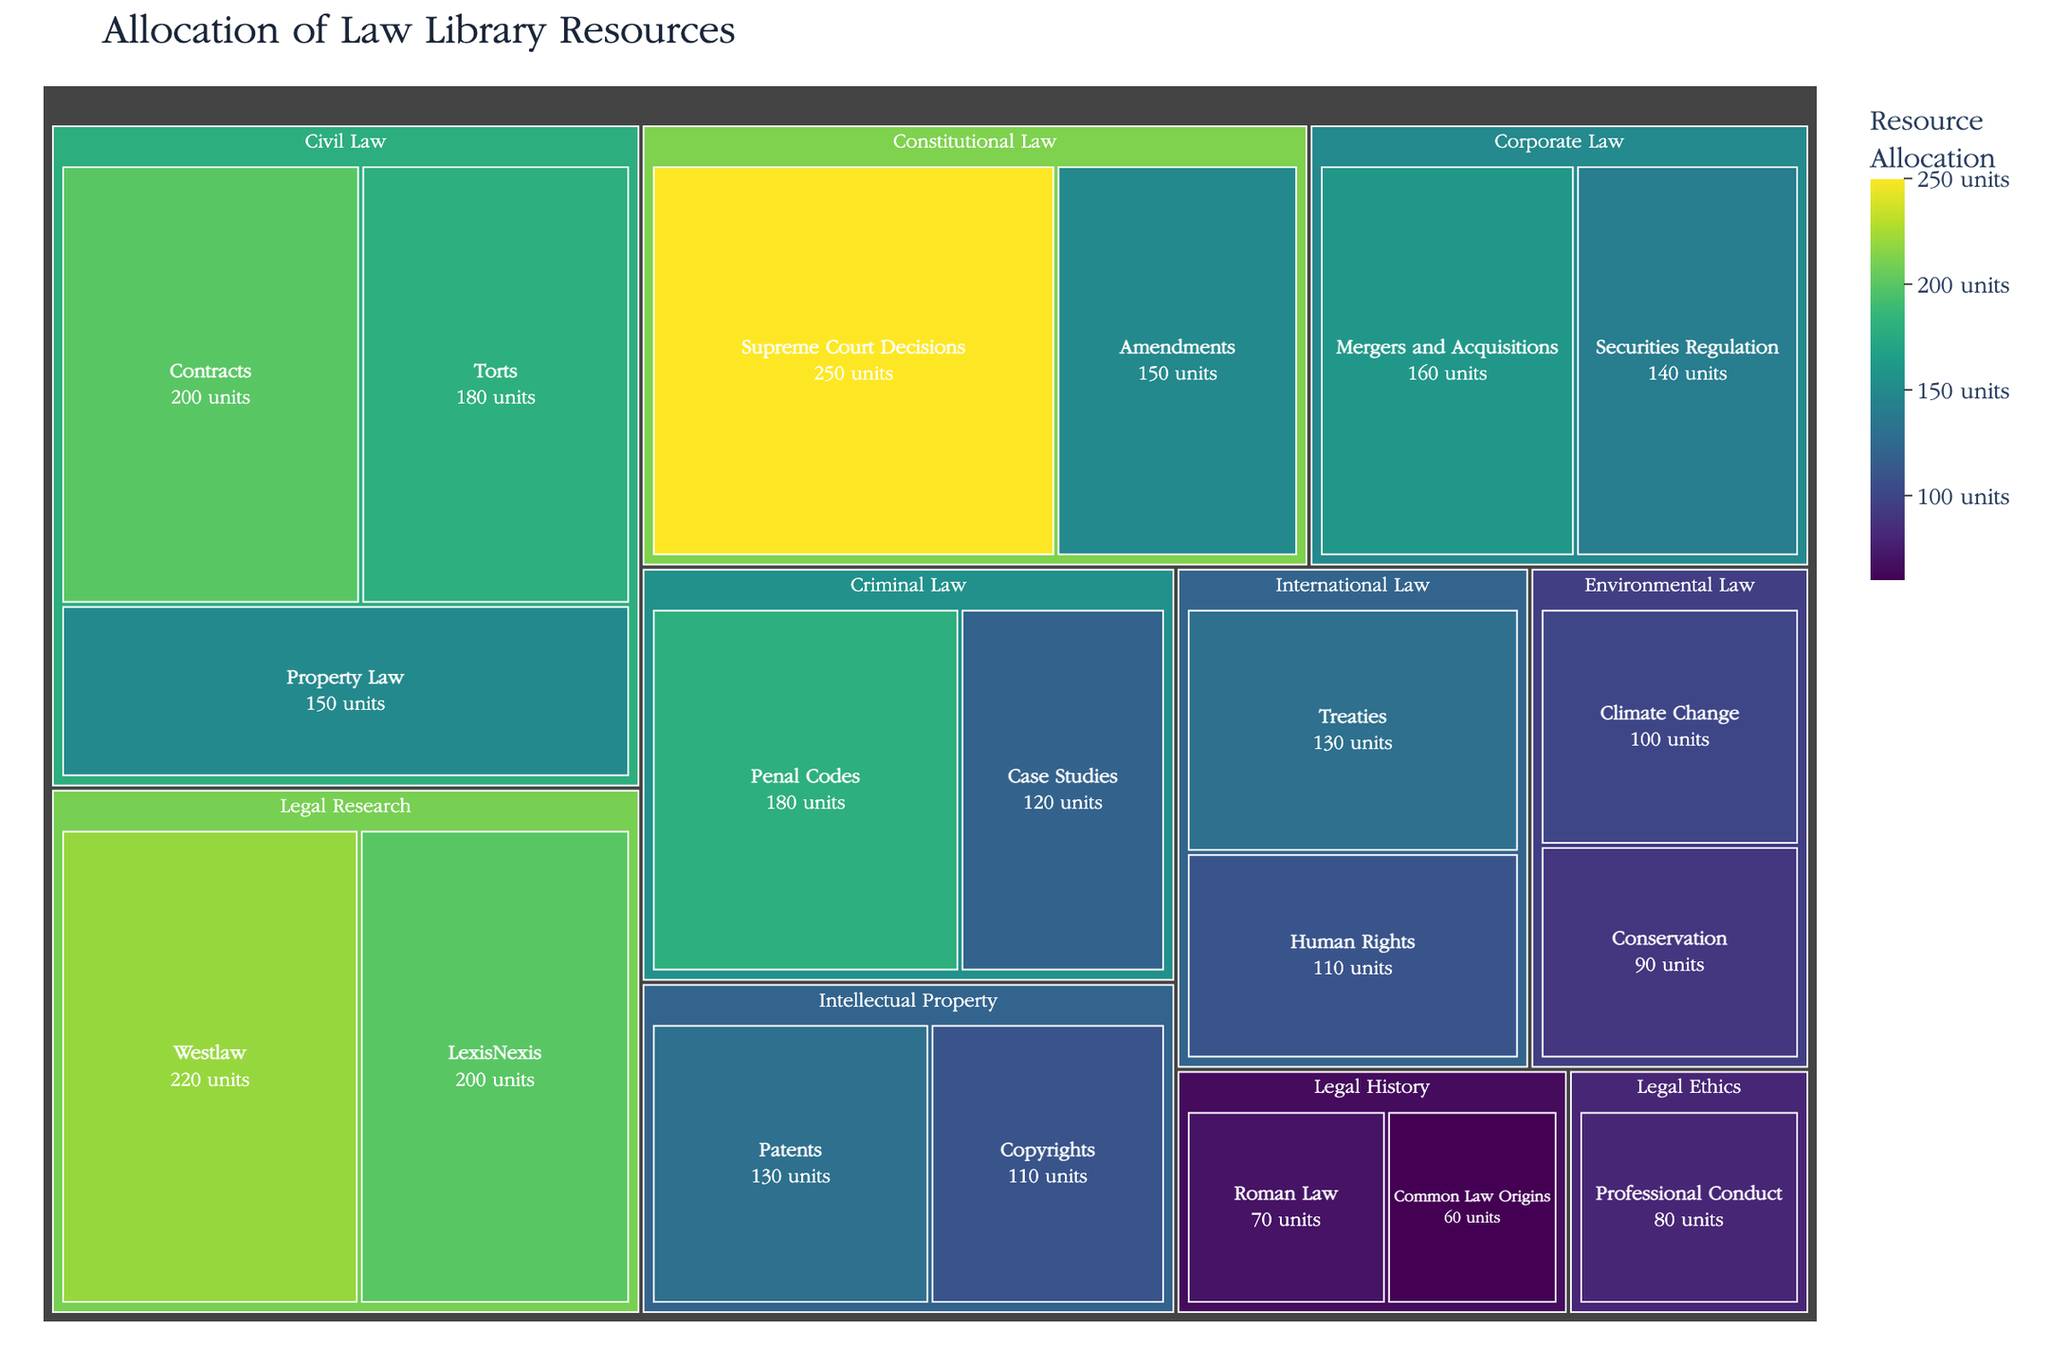What's the category with the highest resource allocation? By examining the treemap, we notice the size of the segment representing "Legal Research" is the largest, indicating that it has the highest resource allocation.
Answer: Legal Research Which subcategory in Constitutional Law has more resources allocated: Supreme Court Decisions or Amendments? Looking at the treemap sections within Constitutional Law, the Sublabel for Supreme Court Decisions has a higher numerical value compared to Amendments. Hence, Supreme Court Decisions have more resources.
Answer: Supreme Court Decisions What's the combined resource allocation for Criminal Law? To find the total resources for Criminal Law, add the values for both subcategories: Penal Codes (180) and Case Studies (120). \[180 + 120 = 300\]
Answer: 300 Which category has the least resource allocation and what is the value? The smallest segment in the treemap represents "Legal History," and the combined values for Roman Law and Common Law Origins determine its total. The segment size and color indicate the overall minimum size.
Answer: Legal History, 130 How do the resources allocated to Environmental Law compare to Intellectual Property? To compare, add the values of Environmental Law (Climate Change 100 + Conservation 90) and Intellectual Property (Patents 130 + Copyrights 110). Then evaluate the differences: \[Environmental Law: 100 + 90 = 190\] \[Intellectual Property: 130 + 110 = 240\]
Answer: Intellectual Property has more resources What is the total number of subcategories displayed in the treemap? Count the distinct subcategories listed under each category in the treemap. The total is nineteen.
Answer: 19 Which specific subcategory has the smallest resource allocation, and what is the value? The smallest segment within the treemap belongs to "Common Law Origins" in Legal History, as visually evident from its smallest size and color intensity.
Answer: Common Law Origins, 60 What's the total value allocated to all historical resources? Add the values for Roman Law (70) and Common Law Origins (60) to get the total resource allocation for Legal History: \[70 + 60 = 130\]
Answer: 130 Which category receives more allocation: Corporate Law or Civil Law, and by how much? Calculate both totals and compare: \[Corporate Law: Mergers and Acquisitions 160 + Securities Regulation 140 = 300\] \[Civil Law: Contracts 200 + Torts 180 + Property Law 150 = 530\] Subtract to find the difference: \[530 - 300 = 230\]
Answer: Civil Law by 230 What subcategory in Legal Research requires more resources, and what is the value? Compare the subcategories Westlaw (220) and LexisNexis (200); Westlaw has the higher value.
Answer: Westlaw, 220 